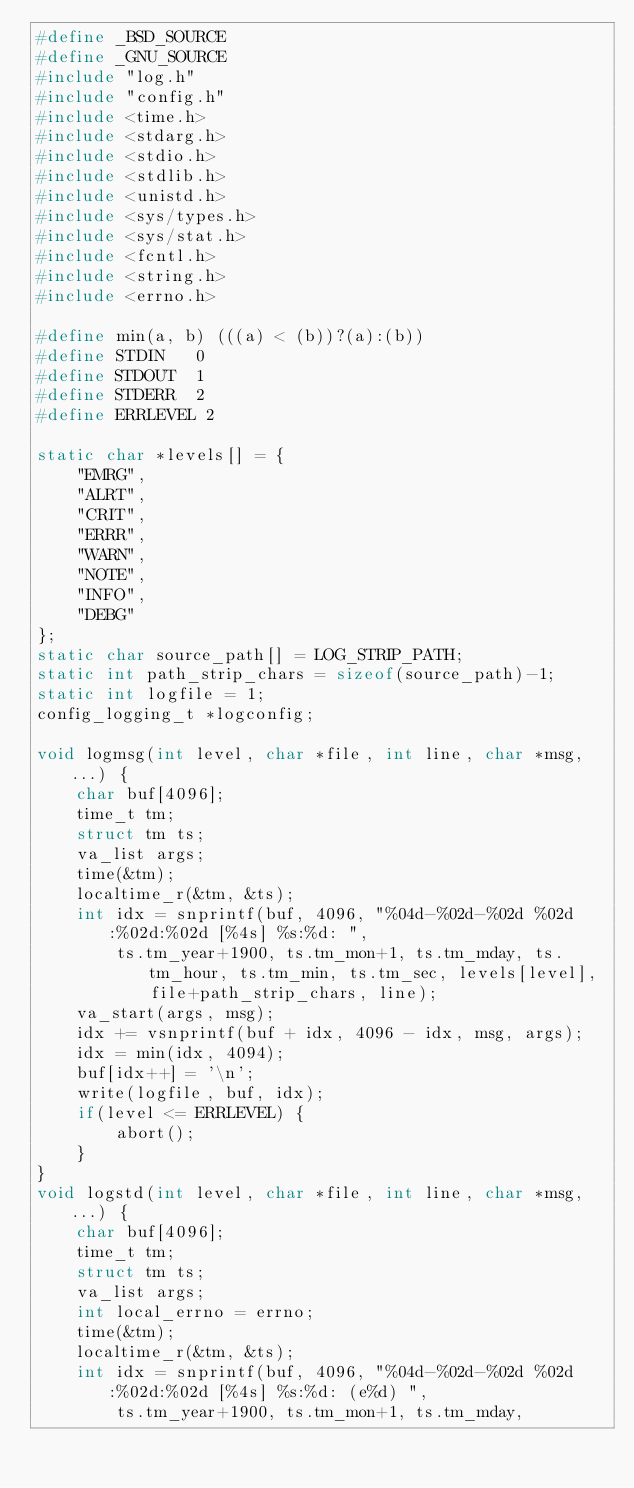Convert code to text. <code><loc_0><loc_0><loc_500><loc_500><_C_>#define _BSD_SOURCE
#define _GNU_SOURCE
#include "log.h"
#include "config.h"
#include <time.h>
#include <stdarg.h>
#include <stdio.h>
#include <stdlib.h>
#include <unistd.h>
#include <sys/types.h>
#include <sys/stat.h>
#include <fcntl.h>
#include <string.h>
#include <errno.h>

#define min(a, b) (((a) < (b))?(a):(b))
#define STDIN   0
#define STDOUT  1
#define STDERR  2
#define ERRLEVEL 2

static char *levels[] = {
    "EMRG",
    "ALRT",
    "CRIT",
    "ERRR",
    "WARN",
    "NOTE",
    "INFO",
    "DEBG"
};
static char source_path[] = LOG_STRIP_PATH;
static int path_strip_chars = sizeof(source_path)-1;
static int logfile = 1;
config_logging_t *logconfig;

void logmsg(int level, char *file, int line, char *msg, ...) {
    char buf[4096];
    time_t tm;
    struct tm ts;
    va_list args;
    time(&tm);
    localtime_r(&tm, &ts);
    int idx = snprintf(buf, 4096, "%04d-%02d-%02d %02d:%02d:%02d [%4s] %s:%d: ",
        ts.tm_year+1900, ts.tm_mon+1, ts.tm_mday, ts.tm_hour, ts.tm_min, ts.tm_sec, levels[level], file+path_strip_chars, line);
    va_start(args, msg);
    idx += vsnprintf(buf + idx, 4096 - idx, msg, args);
    idx = min(idx, 4094);
    buf[idx++] = '\n';
    write(logfile, buf, idx);
    if(level <= ERRLEVEL) {
        abort();
    }
}
void logstd(int level, char *file, int line, char *msg, ...) {
    char buf[4096];
    time_t tm;
    struct tm ts;
    va_list args;
    int local_errno = errno;
    time(&tm);
    localtime_r(&tm, &ts);
    int idx = snprintf(buf, 4096, "%04d-%02d-%02d %02d:%02d:%02d [%4s] %s:%d: (e%d) ",
        ts.tm_year+1900, ts.tm_mon+1, ts.tm_mday,</code> 